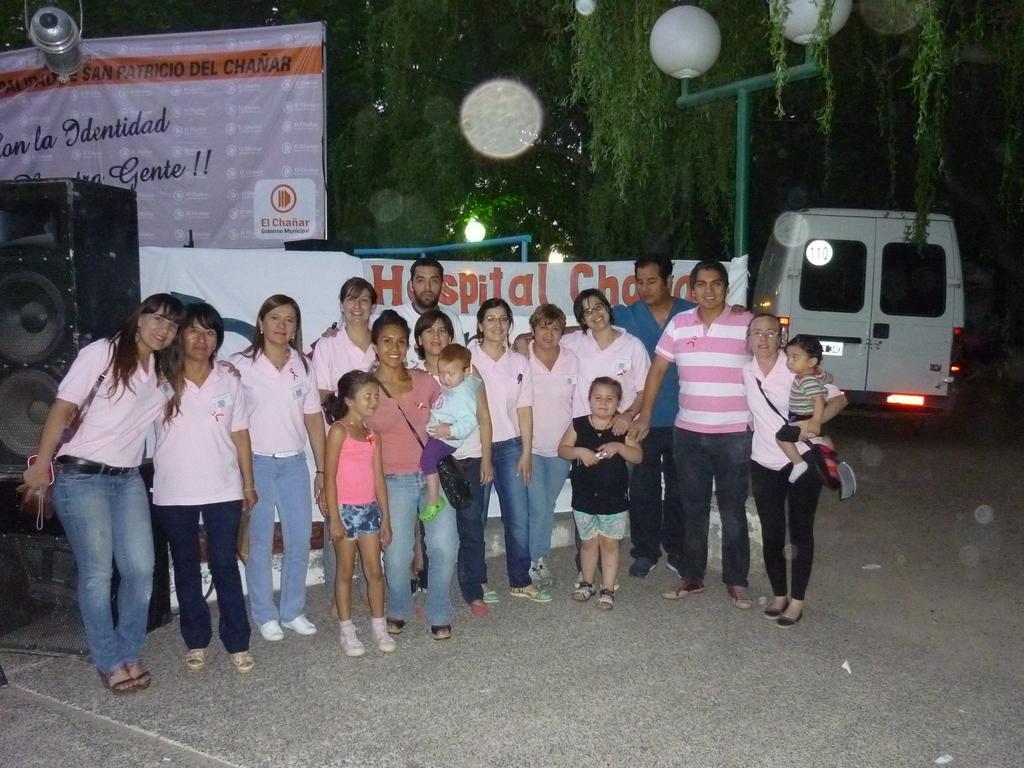In one or two sentences, can you explain what this image depicts? In this image there are few persons standing on the road. Behind them there are few banners. Left side there is a sound speaker. Left top there is a light hanged. Behind the banner there is a street light. Right side there is a vehicle on the road. Background there are few trees. Middle of the image there is a woman holding a baby in her arms. Beside her there is a girl standing on the road. 